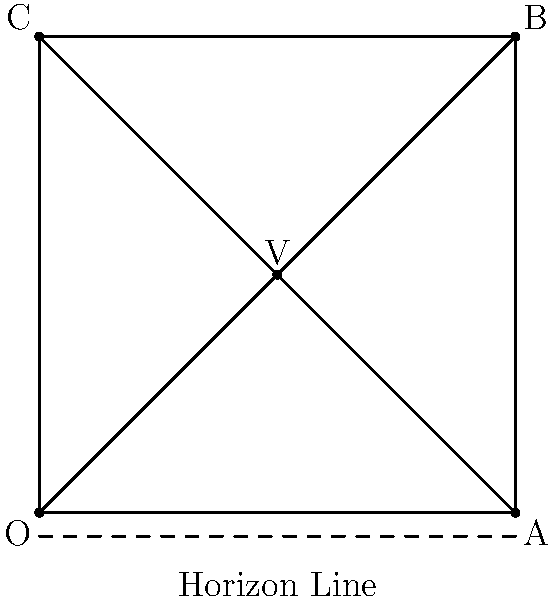In this Renaissance painting representation, point V is known as the vanishing point. If the distance between points O and A is 10 meters in the real world, and the angle formed by OVA is 45°, what is the approximate distance (in meters) between the viewer and the vanishing point V? To solve this problem, we'll use the properties of perspective drawing and basic trigonometry:

1. In a one-point perspective drawing, the vanishing point V lies on the horizon line, which is at the viewer's eye level.

2. The line OV represents the distance from the viewer to the vanishing point.

3. The angle OVA is given as 45°, which means triangle OVA is an isosceles right triangle.

4. In an isosceles right triangle, the two legs are equal. This means OV = VA.

5. We're told that OA is 10 meters in the real world.

6. Since OV = VA, and OA = OV + VA, we can conclude that OV is half of OA.

7. Therefore, the distance from the viewer to the vanishing point (OV) is:

   $$ OV = \frac{OA}{2} = \frac{10}{2} = 5 \text{ meters} $$

Thus, the distance between the viewer and the vanishing point V is approximately 5 meters.
Answer: 5 meters 